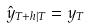<formula> <loc_0><loc_0><loc_500><loc_500>\hat { y } _ { T + h | T } = y _ { T }</formula> 